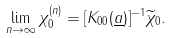Convert formula to latex. <formula><loc_0><loc_0><loc_500><loc_500>\lim _ { n \rightarrow \infty } \chi _ { 0 } ^ { ( n ) } = [ K _ { 0 0 } ( \underline { a } ) ] ^ { - 1 } \widetilde { \chi } _ { 0 } .</formula> 